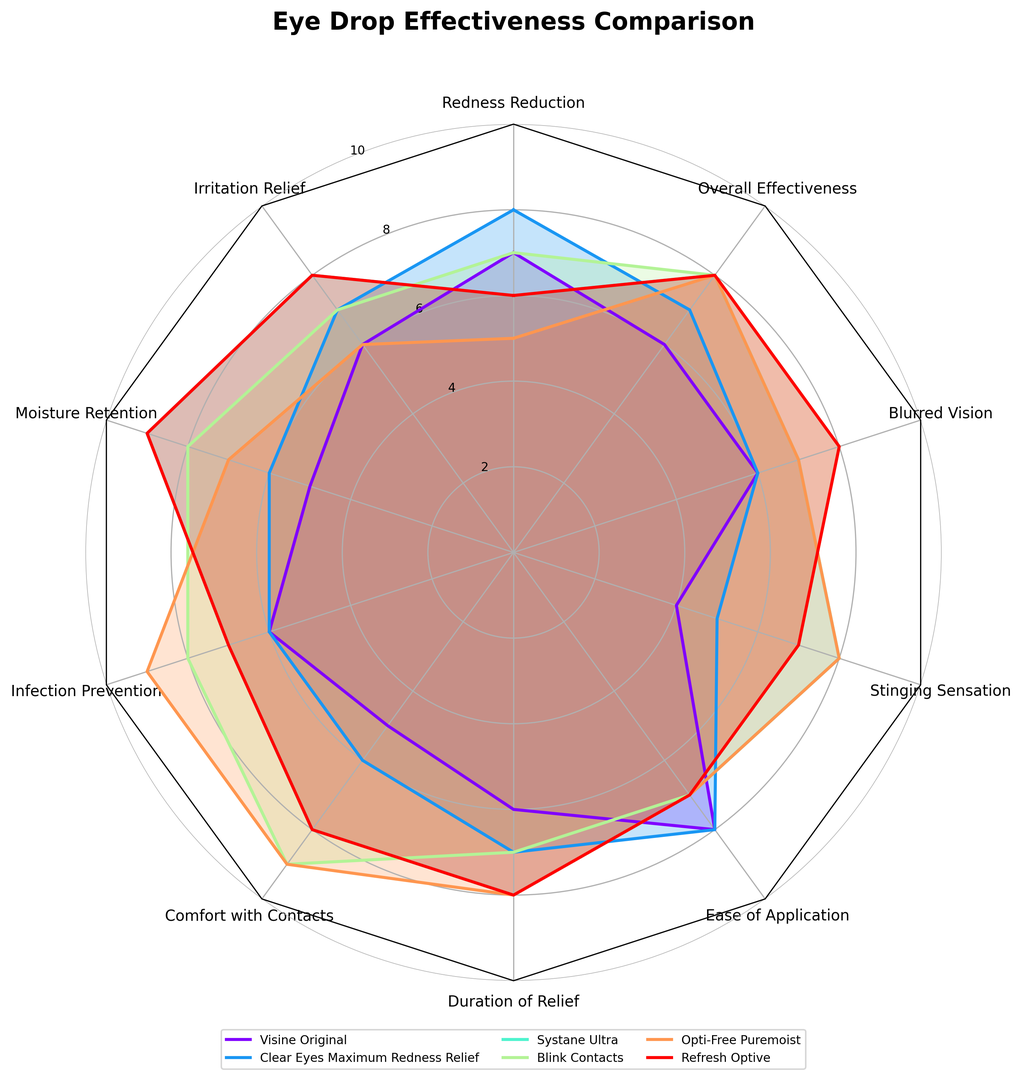Which eye drop is rated highest for infection prevention? Look at the corresponding section of the radar chart for infection prevention and identify the highest value.
Answer: Opti-Free Puremoist Which eye drop provides the best moisture retention? Check the radar chart values for moisture retention across all eye drops. The highest value indicates the best moisture retention.
Answer: Systane Ultra & Refresh Optive Which eye drop scores the highest for comfort with contacts? Review the radar chart section for comfort with contacts. The highest value represents the best comfort.
Answer: Opti-Free Puremoist and Blink Contacts Which eye drop has the highest overall effectiveness? Look at the radar chart values for overall effectiveness to identify the highest rating.
Answer: Systane Ultra, Blink Contacts, Opti-Free Puremoist, and Refresh Optive What is the difference in irritation relief between Visine Original and Systane Ultra? Find the values for irritation relief for Visine Original and Systane Ultra on the radar chart, then compute the difference.
Answer: 2 Are there any eye drops that score equally in redness reduction? Identify any two or more eye drops with the same value for redness reduction on the chart.
Answer: Visine Original and Blink Contacts Which eye drop has the lowest rating for stinging sensation? Observe the radar chart values for stinging sensation and note the lowest value, indicating the least stinging sensation.
Answer: Visine Original Which two eye drops are most similar in terms of duration of relief? Compare the ratings for the duration of relief and find the two eye drops with the closest values.
Answer: Systane Ultra and Refresh Optive Is there a significant difference between the highest and lowest ratings for ease of application? Identify the highest and lowest values for ease of application, then compute their difference.
Answer: Yes, 1 